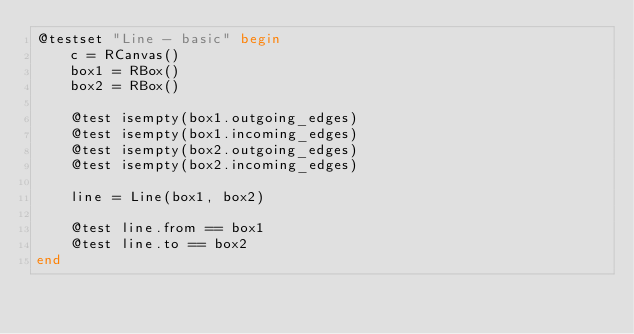Convert code to text. <code><loc_0><loc_0><loc_500><loc_500><_Julia_>@testset "Line - basic" begin
    c = RCanvas()
    box1 = RBox()
    box2 = RBox()

    @test isempty(box1.outgoing_edges)
    @test isempty(box1.incoming_edges)
    @test isempty(box2.outgoing_edges)
    @test isempty(box2.incoming_edges)

    line = Line(box1, box2)

    @test line.from == box1
    @test line.to == box2
end
</code> 